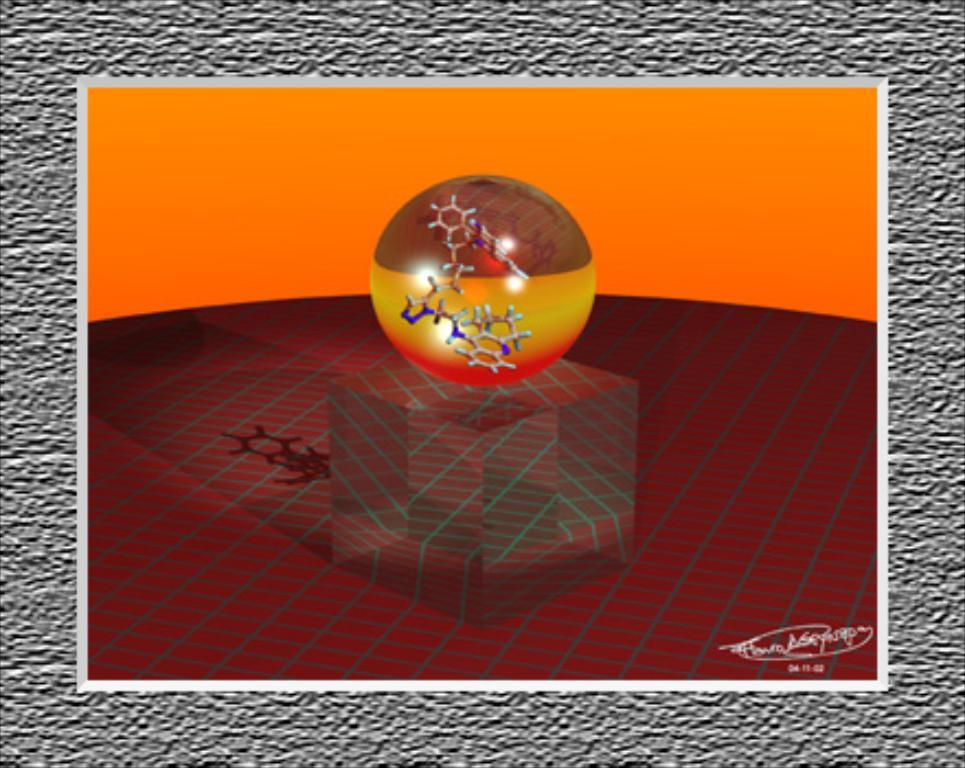What shape is the main object in the image? There is a cube in the image. What geometric shape is on the cube? There is a circle on the cube. What colors are present on the cube? The cube has maroon, red, yellow, and brown colors. What color is the background of the image? The background of the image is orange. What type of furniture can be seen in the image? There is no furniture present in the image; it features a cube with a circle on it. What is the ground made of in the image? There is no ground present in the image; it features a cube with a circle on it against an orange background. 